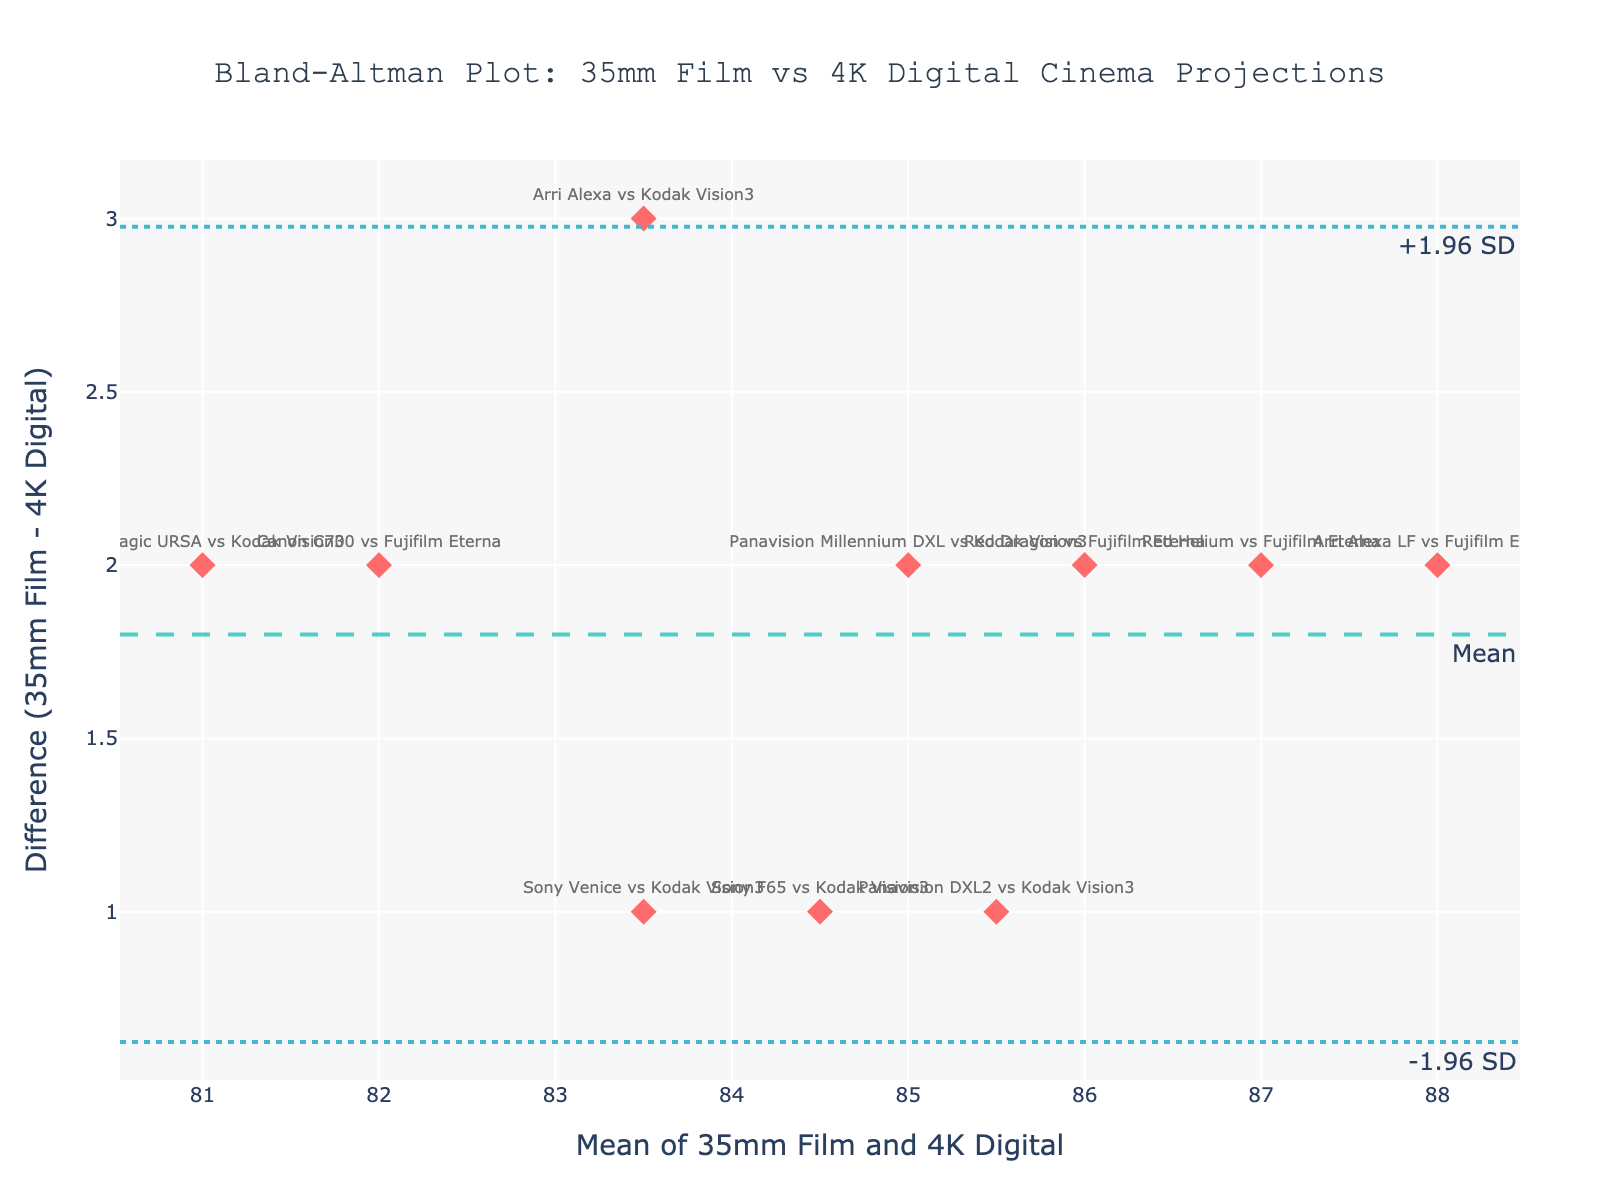what is the difference between perceived sharpness for Arri Alexa vs Kodak Vision3, and Sony Venice vs Kodak Vision3? Locate the points labeled "Arri Alexa vs Kodak Vision3" and "Sony Venice vs Kodak Vision3". The vertical axis (Difference) shows the difference in perceived sharpness. Arri Alexa vs Kodak Vision3 has a difference of 3, and Sony Venice vs Kodak Vision3 has a difference of 1.
Answer: 3 and 1 How many data points fall below the mean difference line? Count the number of points below the dashed line representing the mean difference. There are 6 points below the mean difference line.
Answer: 6 Which method has the highest mean sharpness? Look at the x-axis values (Mean) and identify the highest value. "Arri Alexa LF vs Fujifilm Eterna" has a mean sharpness value of 88.
Answer: Arri Alexa LF vs Fujifilm Eterna What are the coordinates (Mean, Difference) for Blackmagic URSA vs Kodak Vision3? Find the point labeled "Blackmagic URSA vs Kodak Vision3". The coordinates from the figure show Mean = 81 and Difference = 2.
Answer: (81, 2) Does any method's difference in perceived sharpness fall on the upper limit of agreement? Look for points that fall exactly on the dotted line representing +1.96 SD. There are no points on this line.
Answer: No What is the average of the differences in perceived sharpness for all methods? Sum the differences and divide by the number of data points. Differences are: 3, 2, 1, 1, 2, 2, 2, 1, 2, 2. Average is (3+2+1+1+2+2+2+1+2+2)/10 = 1.8
Answer: 1.8 Is there a method with the same perceived sharpness difference as the mean difference? Identify the mean difference line, which is at 1.8, and compare it to each method's difference. There is no method with exactly the same difference as the mean difference.
Answer: No Which methods have a mean sharpness greater than 86? Look at the x-axis values (Mean) and find methods with values greater than 86. The methods are "Red Helium vs Fujifilm Eterna" (87), "Arri Alexa LF vs Fujifilm Eterna" (88), and "Canon C700 vs Fujifilm Eterna" (82).
Answer: Red Helium vs Fujifilm Eterna, Arri Alexa LF vs Fujifilm Eterna What can you say about the overall trend of differences in perceived sharpness between 35mm film and 4K digital? Most data points are clustered around small positive differences, indicating that the perceived sharpness difference is minimal between the two formats. The trend shows a slight preference for 35mm film being perceived sharper than 4K digital.
Answer: Minimal differences, slight preference for 35mm 